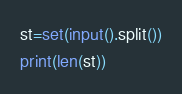Convert code to text. <code><loc_0><loc_0><loc_500><loc_500><_Python_>st=set(input().split())
print(len(st))</code> 